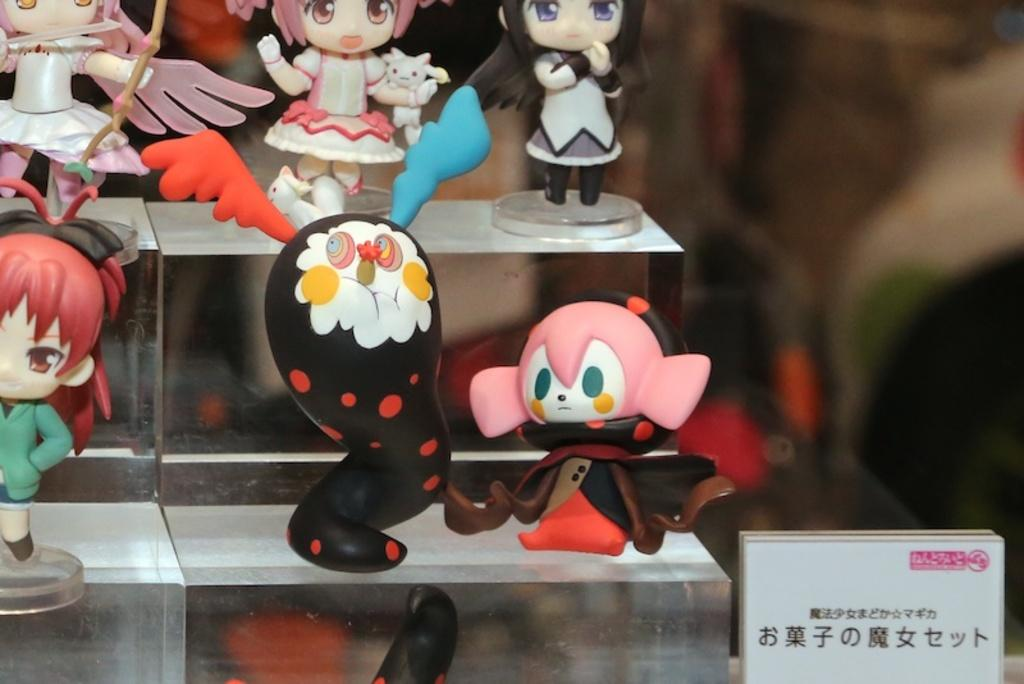What objects are present in the image? There are toys in the image. Where are the toys located? The toys are placed on an object. What type of cheese is being used to build the toys in the image? There is no cheese present in the image, and the toys are not being built. 